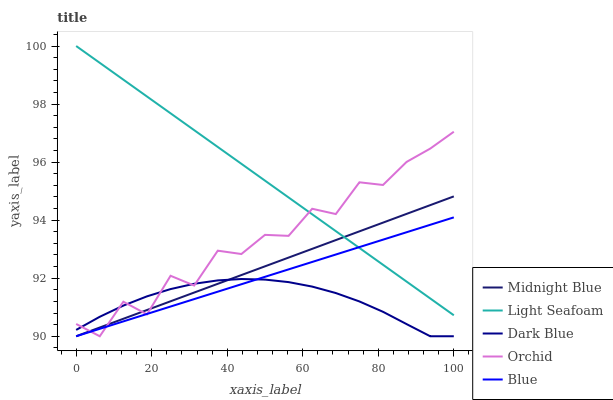Does Dark Blue have the minimum area under the curve?
Answer yes or no. Yes. Does Light Seafoam have the maximum area under the curve?
Answer yes or no. Yes. Does Light Seafoam have the minimum area under the curve?
Answer yes or no. No. Does Dark Blue have the maximum area under the curve?
Answer yes or no. No. Is Blue the smoothest?
Answer yes or no. Yes. Is Orchid the roughest?
Answer yes or no. Yes. Is Dark Blue the smoothest?
Answer yes or no. No. Is Dark Blue the roughest?
Answer yes or no. No. Does Light Seafoam have the lowest value?
Answer yes or no. No. Does Light Seafoam have the highest value?
Answer yes or no. Yes. Does Dark Blue have the highest value?
Answer yes or no. No. Is Dark Blue less than Light Seafoam?
Answer yes or no. Yes. Is Light Seafoam greater than Dark Blue?
Answer yes or no. Yes. Does Midnight Blue intersect Dark Blue?
Answer yes or no. Yes. Is Midnight Blue less than Dark Blue?
Answer yes or no. No. Is Midnight Blue greater than Dark Blue?
Answer yes or no. No. Does Dark Blue intersect Light Seafoam?
Answer yes or no. No. 